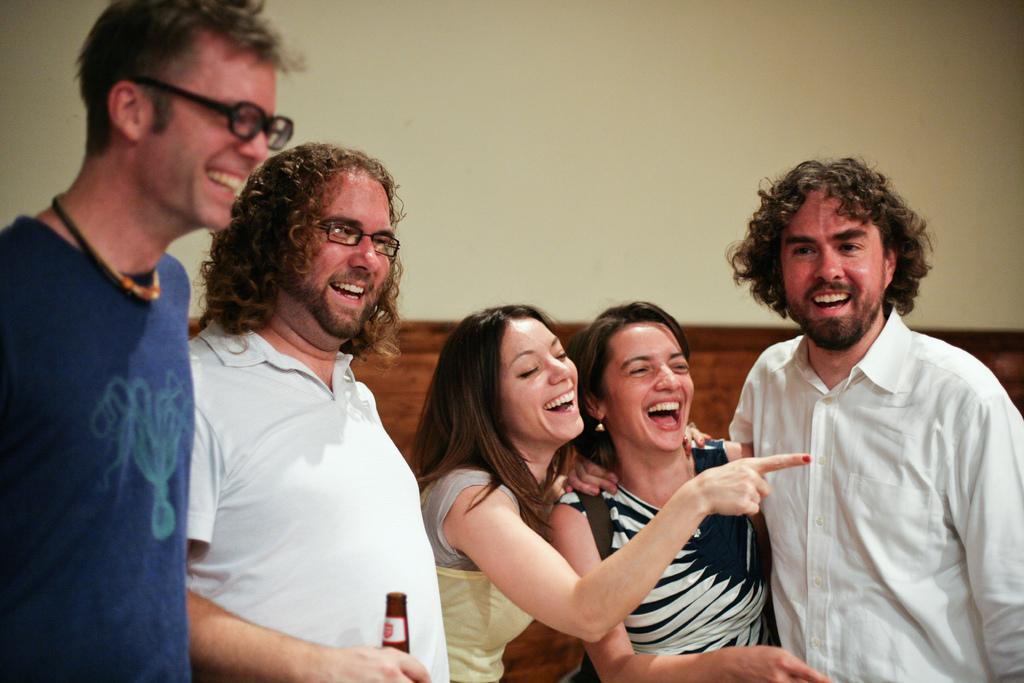How would you summarize this image in a sentence or two? In this image in the center there are persons smiling. The man in the center is standing and smiling is holding a bottle in his hand. 